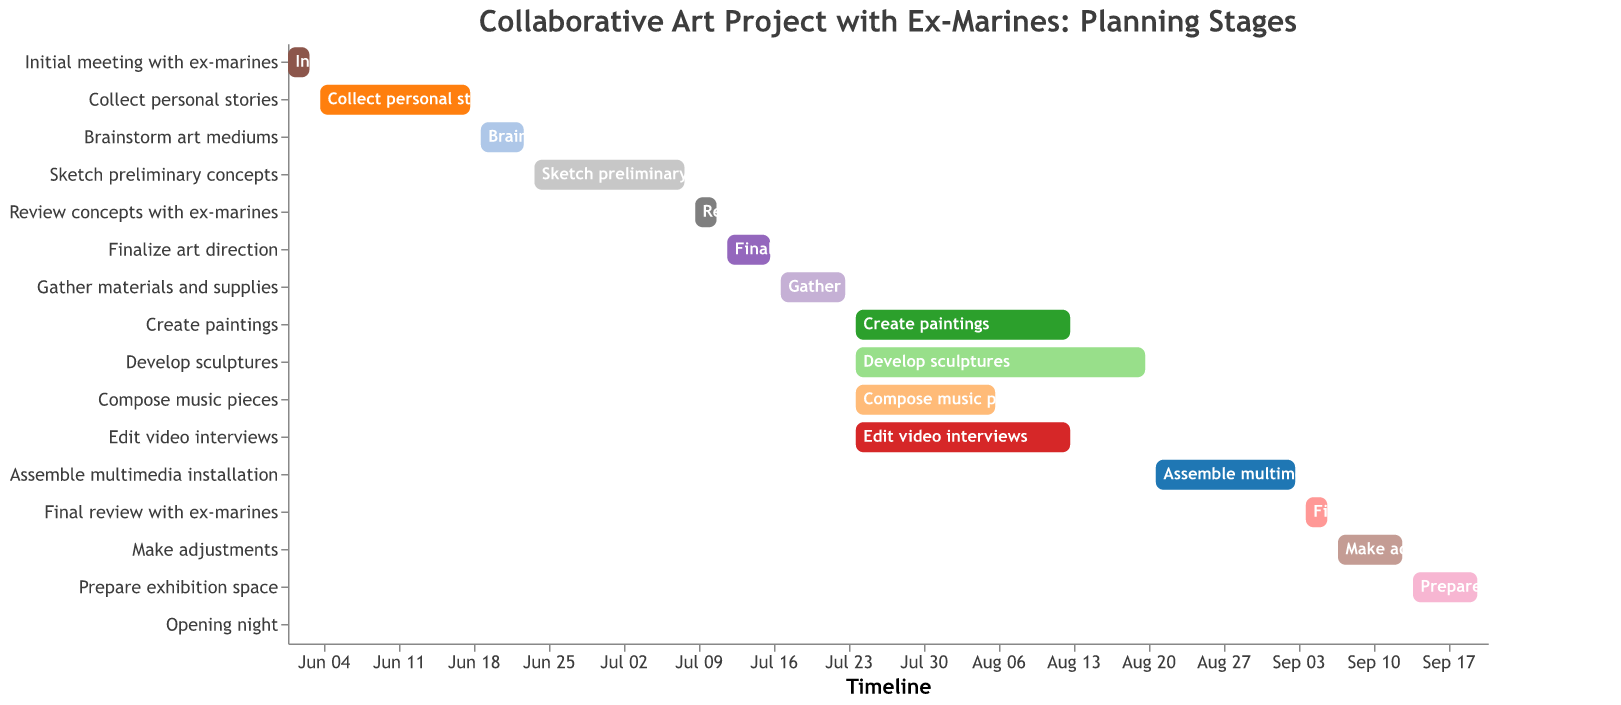What is the title of the Gantt Chart? The title is displayed at the top of the chart, and it reads "Collaborative Art Project with Ex-Marines: Planning Stages."
Answer: Collaborative Art Project with Ex-Marines: Planning Stages How many tasks are involved in the project? Each horizontal bar in the Gantt Chart represents a task, and by counting these bars, we can see there are 16 tasks.
Answer: 16 What is the duration of the "Develop sculptures" task? The end date of the "Develop sculptures" task is listed as 2023-08-20, and the start date is 2023-07-24. Subtracting the start date from the end date, we get 28 days, as specified in the data.
Answer: 28 days Which task starts first in the timeline? By looking at the start date on the x-axis, the "Initial meeting with ex-marines" task starts first on 2023-06-01.
Answer: Initial meeting with ex-marines Which task has the longest duration? By comparing the durations listed, "Develop sculptures" has the longest duration of 28 days.
Answer: Develop sculptures What tasks overlap with the "Create paintings" task? By observing the Gantt Chart, the tasks "Develop sculptures," "Compose music pieces," and "Edit video interviews" all overlap in the time frame with the "Create paintings" task from 2023-07-24 to 2023-08-13.
Answer: Develop sculptures, Compose music pieces, Edit video interviews When is the "Opening night" scheduled? The "Opening night" is represented by a single day on the Gantt Chart, which is scheduled for 2023-09-21.
Answer: 2023-09-21 What is the total duration from the "Initial meeting with ex-marines" to the "Opening night"? The project starts on 2023-06-01 with the initial meeting and ends on 2023-09-21 with the opening night. The total duration is the difference between these dates, which is 113 days.
Answer: 113 days Which tasks require review and feedback from ex-marines? The tasks specifically mentioned for review with ex-marines in the chart are "Review concepts with ex-marines" and "Final review with ex-marines."
Answer: Review concepts with ex-marines, Final review with ex-marines 